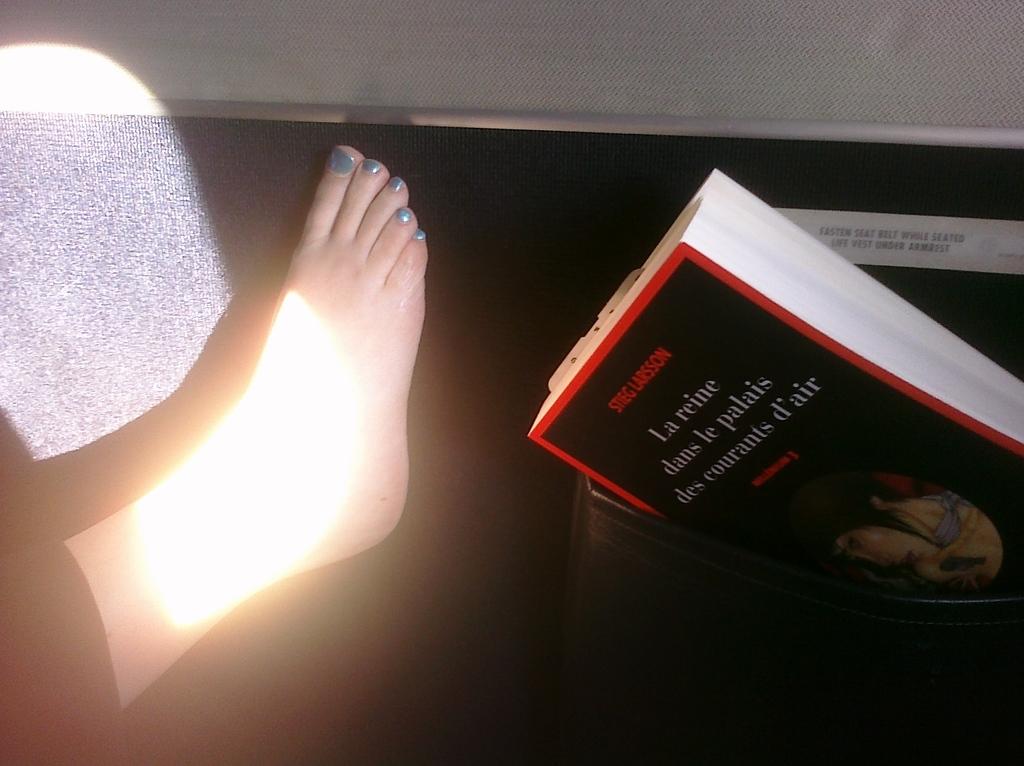What is the author's name of the book at the bottom?
Offer a very short reply. Stieg larsson. What is the first word in the title?
Make the answer very short. La. 